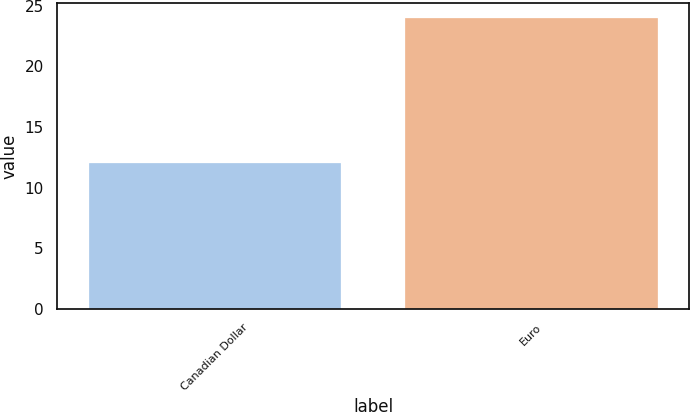Convert chart. <chart><loc_0><loc_0><loc_500><loc_500><bar_chart><fcel>Canadian Dollar<fcel>Euro<nl><fcel>12<fcel>24<nl></chart> 